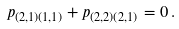<formula> <loc_0><loc_0><loc_500><loc_500>p _ { ( 2 , 1 ) ( 1 , 1 ) } + p _ { ( 2 , 2 ) ( 2 , 1 ) } = 0 \, .</formula> 